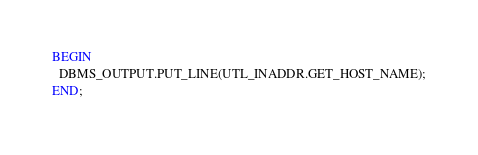<code> <loc_0><loc_0><loc_500><loc_500><_SQL_>BEGIN
  DBMS_OUTPUT.PUT_LINE(UTL_INADDR.GET_HOST_NAME);
END;
</code> 